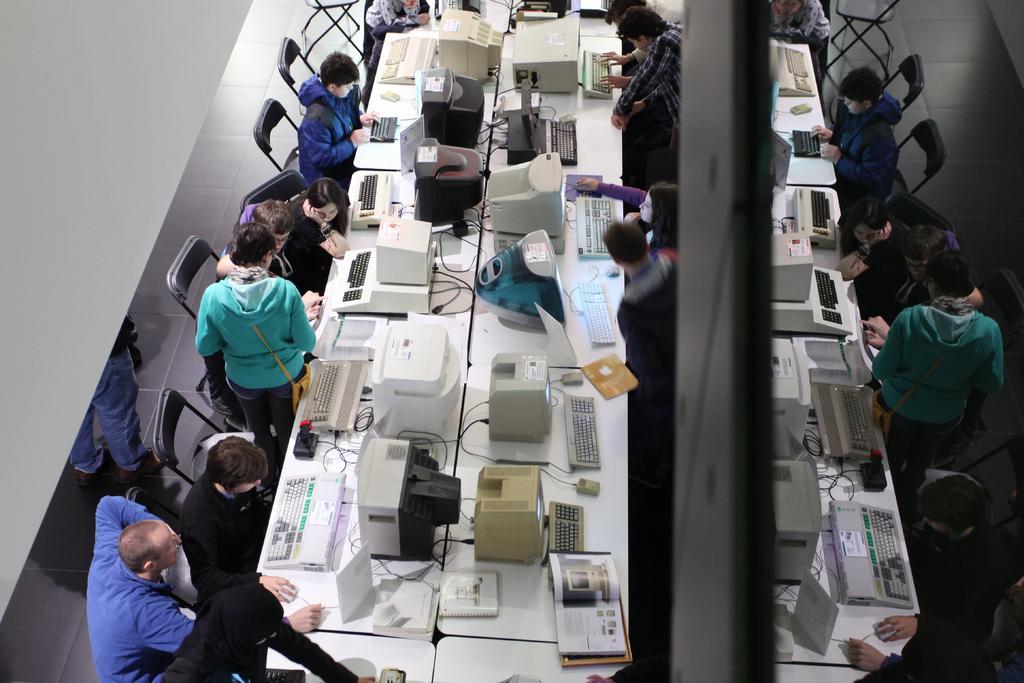How would you summarize this image in a sentence or two? The picture is of a work space. There are many people sitting on chairs, few are standing. On the desks there are systems, keyboards, books, few other things are there. This is the floor. 